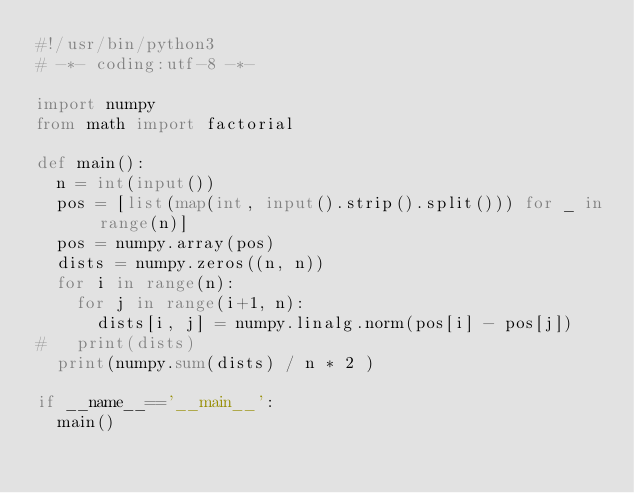Convert code to text. <code><loc_0><loc_0><loc_500><loc_500><_Python_>#!/usr/bin/python3
# -*- coding:utf-8 -*-

import numpy
from math import factorial

def main():
  n = int(input())
  pos = [list(map(int, input().strip().split())) for _ in range(n)]
  pos = numpy.array(pos)
  dists = numpy.zeros((n, n))
  for i in range(n):
    for j in range(i+1, n):
      dists[i, j] = numpy.linalg.norm(pos[i] - pos[j]) 
#   print(dists)
  print(numpy.sum(dists) / n * 2 )

if __name__=='__main__':
  main()

</code> 